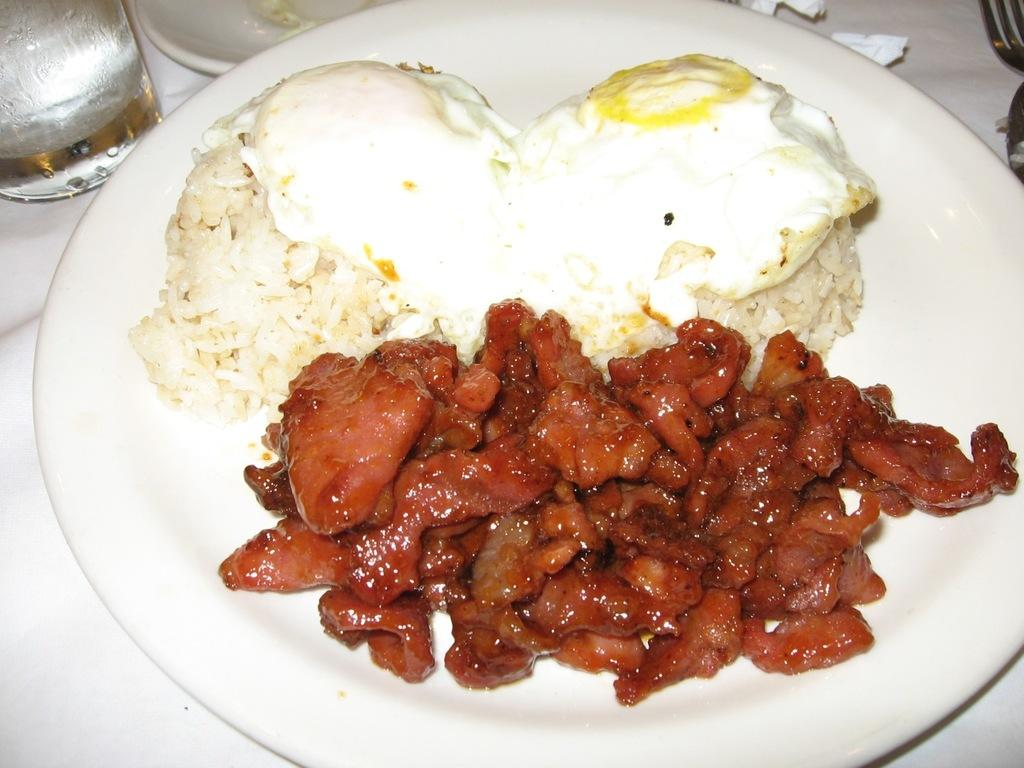What type of food is visible in the image? There is a fried egg and curry in the image. What is the color of the plate that the food is on? The plate is white in color. What type of copper utensil can be seen in the image? There is no copper utensil present in the image. What type of vegetable, such as celery, can be seen in the image? There is no vegetable, including celery, present in the image. 